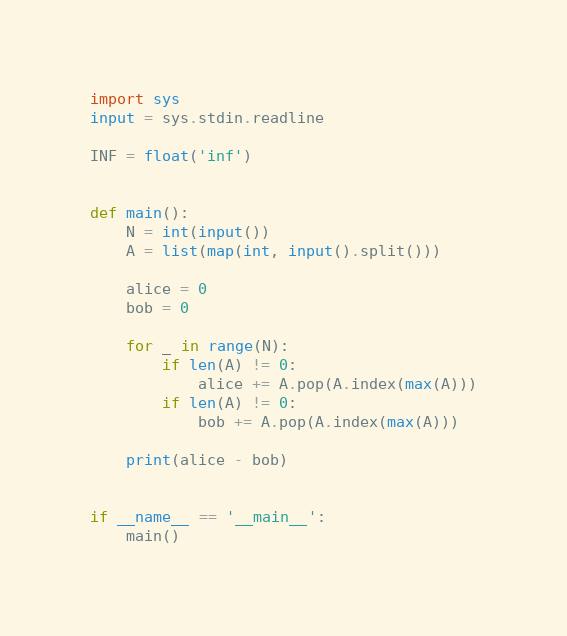<code> <loc_0><loc_0><loc_500><loc_500><_Python_>import sys
input = sys.stdin.readline

INF = float('inf')


def main():
    N = int(input())
    A = list(map(int, input().split()))

    alice = 0
    bob = 0

    for _ in range(N):
        if len(A) != 0:
            alice += A.pop(A.index(max(A)))
        if len(A) != 0:
            bob += A.pop(A.index(max(A)))

    print(alice - bob)


if __name__ == '__main__':
    main()
</code> 